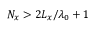Convert formula to latex. <formula><loc_0><loc_0><loc_500><loc_500>N _ { x } > 2 L _ { x } / \lambda _ { 0 } + 1</formula> 